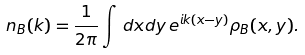<formula> <loc_0><loc_0><loc_500><loc_500>n _ { B } ( k ) = \frac { 1 } { 2 \pi } \int \, d x d y \, e ^ { i k ( x - y ) } \rho _ { B } ( x , y ) .</formula> 